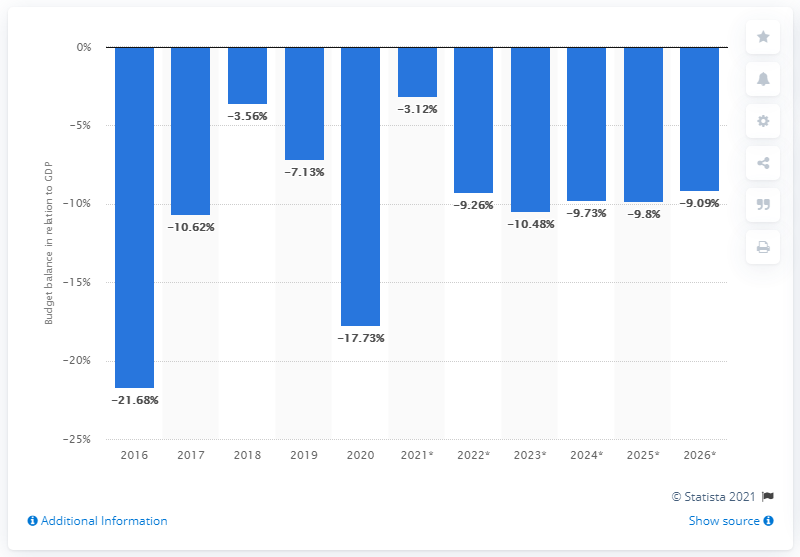Highlight a few significant elements in this photo. When does Brunei Darussalam's budget balance end in 2020? 